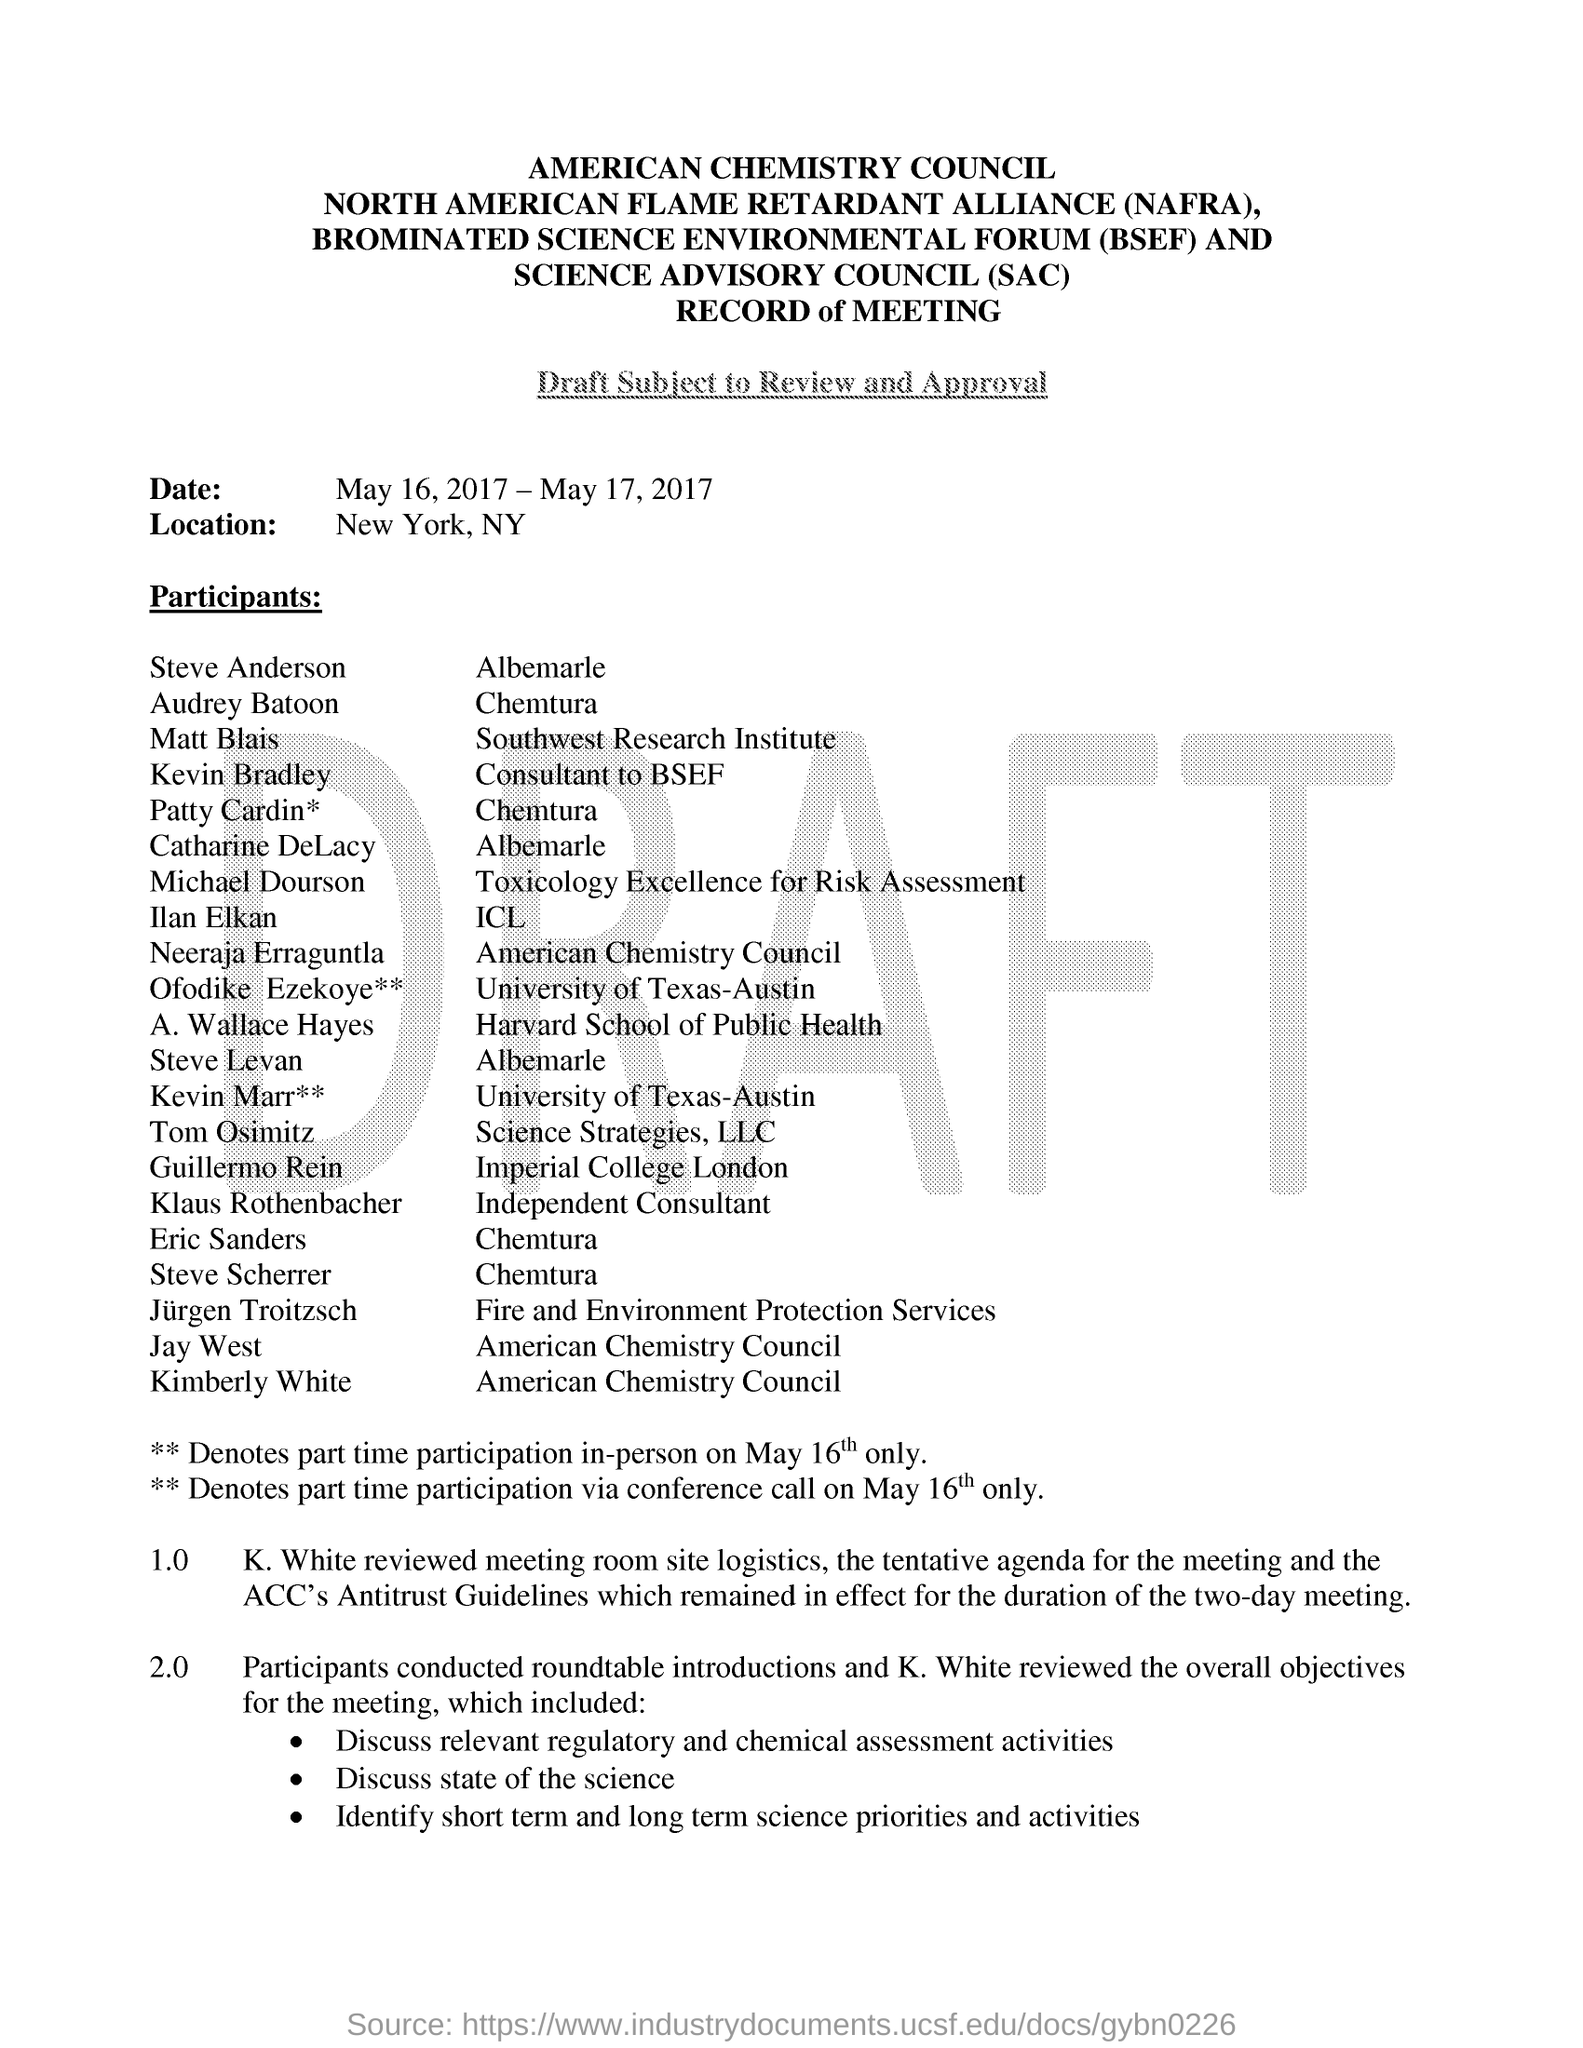Mention a couple of crucial points in this snapshot. The location specified is New York, New York. The overall objectives for the meeting were reviewed by K. White. 